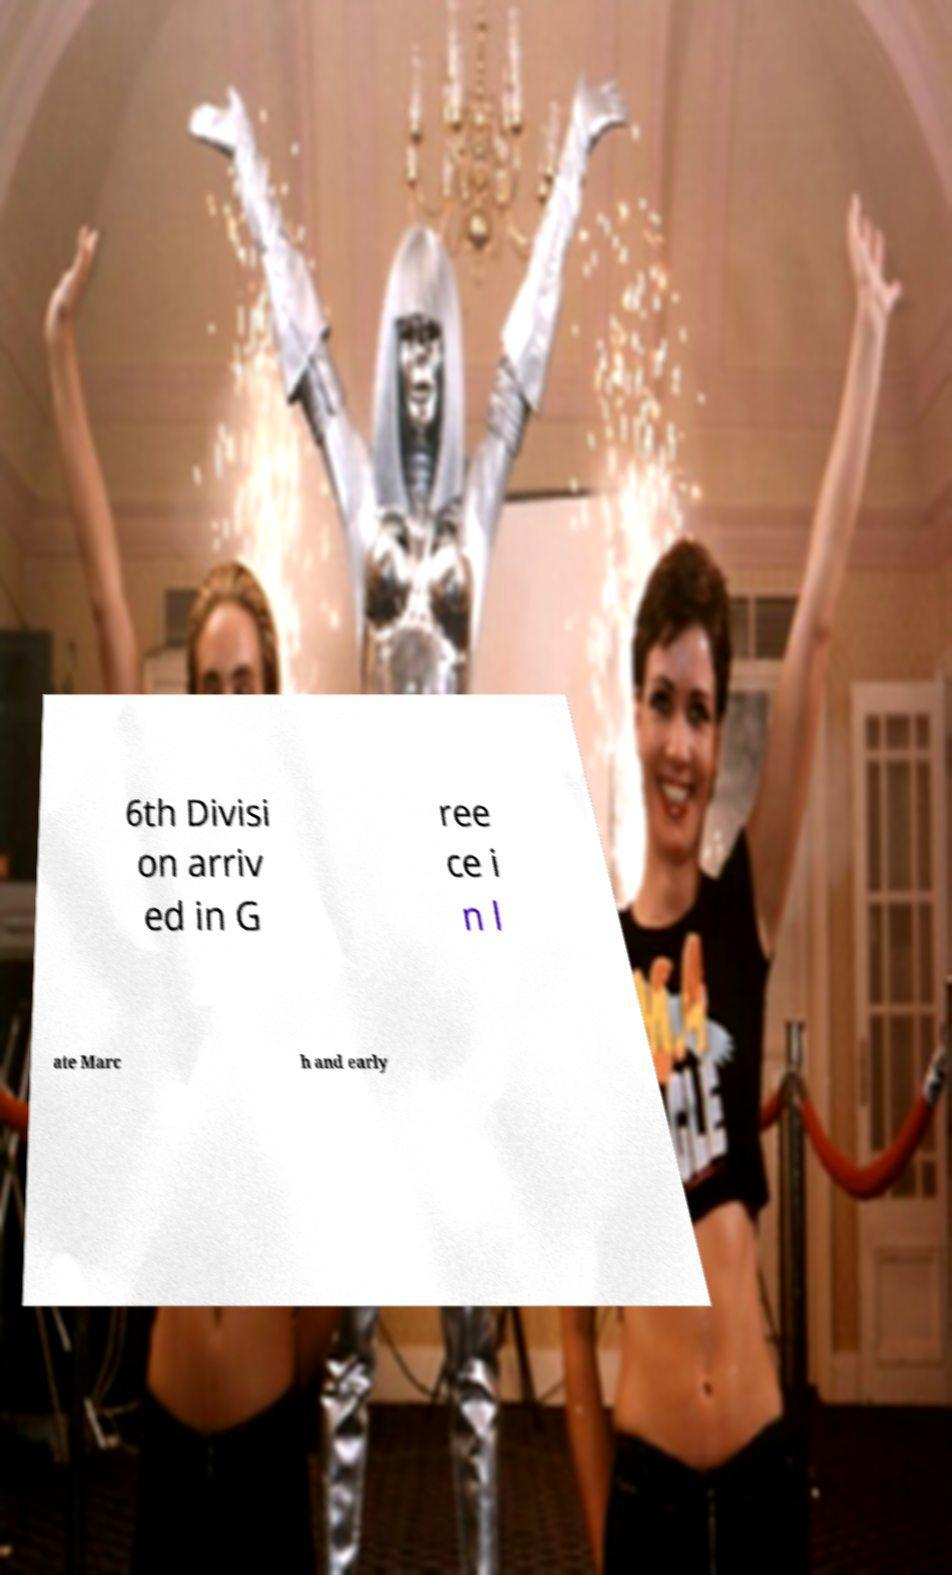Could you extract and type out the text from this image? 6th Divisi on arriv ed in G ree ce i n l ate Marc h and early 